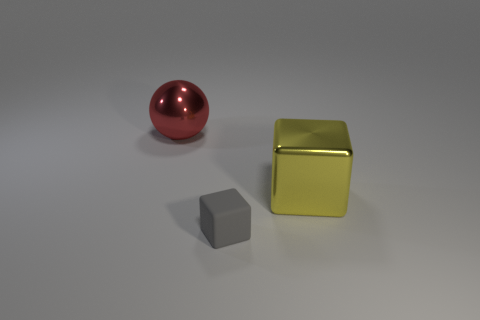There is a big object that is the same shape as the tiny gray rubber object; what is its material?
Ensure brevity in your answer.  Metal. Are there any tiny rubber things that are in front of the object in front of the large object that is right of the large metallic ball?
Offer a terse response. No. There is a red thing; is it the same shape as the thing in front of the big yellow metal cube?
Make the answer very short. No. Are there any other things that have the same color as the big metallic sphere?
Provide a short and direct response. No. There is a large shiny object in front of the large red metallic object; is its color the same as the small matte block that is right of the shiny sphere?
Your answer should be compact. No. Are any big yellow blocks visible?
Provide a succinct answer. Yes. Is there a big yellow object that has the same material as the big yellow cube?
Offer a terse response. No. Is there anything else that has the same material as the red ball?
Keep it short and to the point. Yes. What color is the ball?
Ensure brevity in your answer.  Red. There is a metallic object that is the same size as the red metallic sphere; what color is it?
Offer a very short reply. Yellow. 